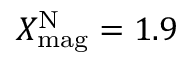<formula> <loc_0><loc_0><loc_500><loc_500>X _ { m a g } ^ { N } = 1 . 9</formula> 